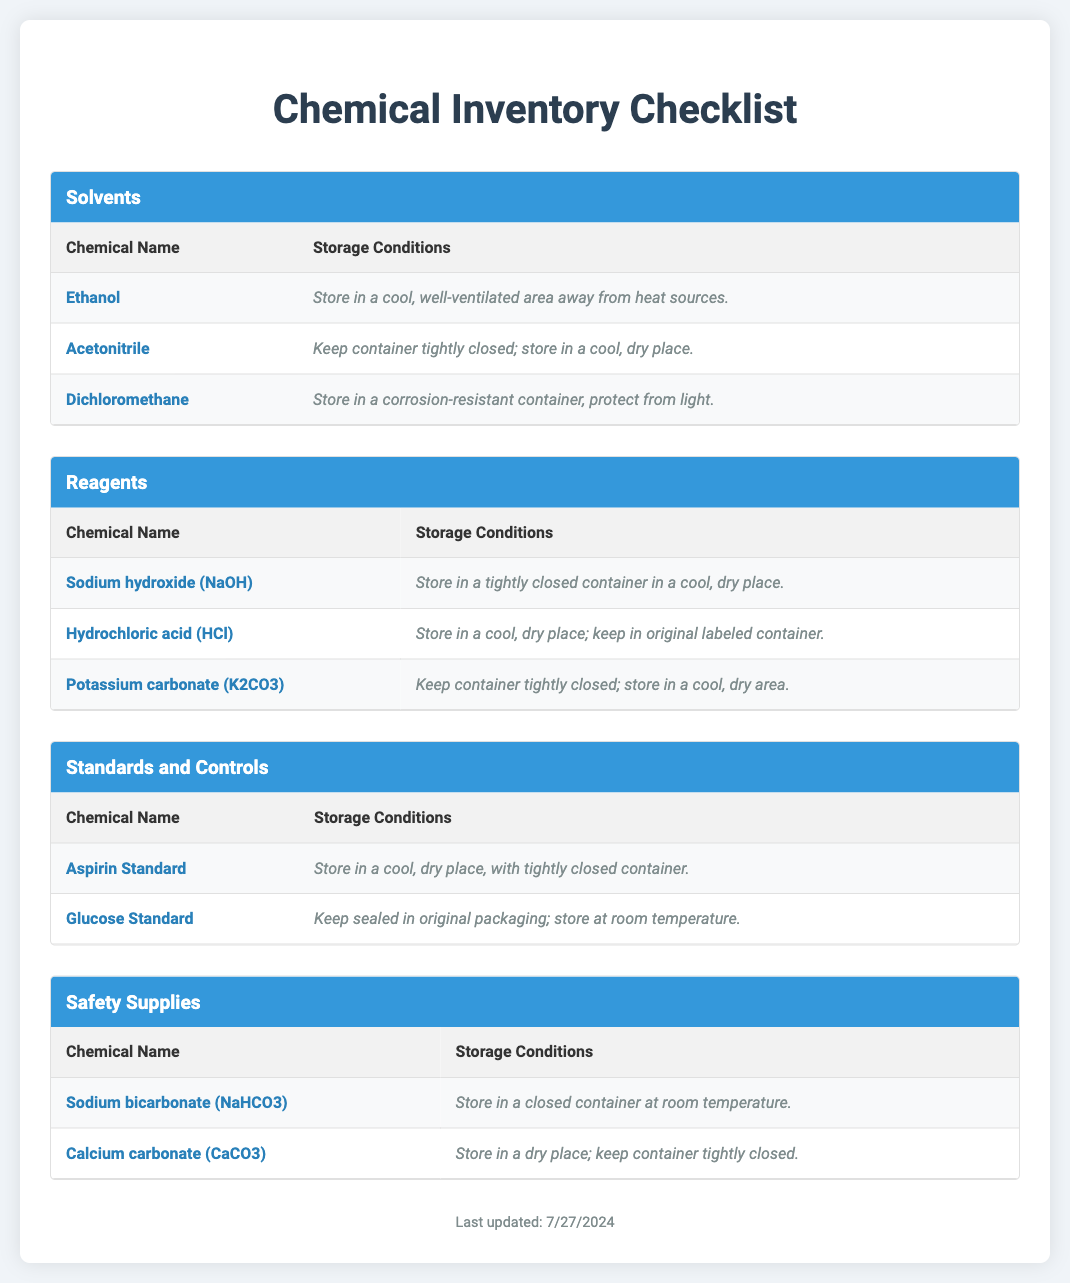What is the storage condition for Ethanol? The storage condition for Ethanol is specified as "Store in a cool, well-ventilated area away from heat sources."
Answer: Store in a cool, well-ventilated area away from heat sources What is the chemical name of the first reagent listed? The first reagent listed in the document is Sodium hydroxide (NaOH).
Answer: Sodium hydroxide (NaOH) How many safety supplies are listed in the document? The document lists two safety supplies, Sodium bicarbonate and Calcium carbonate.
Answer: Two What is the storage condition for Glucose Standard? The storage condition specified for Glucose Standard is "Keep sealed in original packaging; store at room temperature."
Answer: Keep sealed in original packaging; store at room temperature Which solvent is stored in a corrosion-resistant container? The document states that Dichloromethane is stored in a corrosion-resistant container and protected from light.
Answer: Dichloromethane What is the category under which Aspirin Standard is listed? Aspirin Standard is categorized under "Standards and Controls" in the document.
Answer: Standards and Controls What is the total number of chemicals listed in the "Reagents" category? Three chemicals are listed in the "Reagents" category: Sodium hydroxide, Hydrochloric acid, and Potassium carbonate.
Answer: Three What is the last updated date section of the document? The last updated date is dynamically generated in the footer of the document.
Answer: Last updated date is dynamically generated 